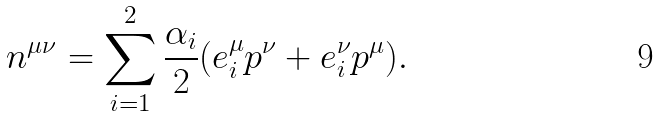<formula> <loc_0><loc_0><loc_500><loc_500>n ^ { \mu \nu } = \sum _ { i = 1 } ^ { 2 } \frac { \alpha _ { i } } { 2 } ( e ^ { \mu } _ { i } p ^ { \nu } + e _ { i } ^ { \nu } p ^ { \mu } ) .</formula> 